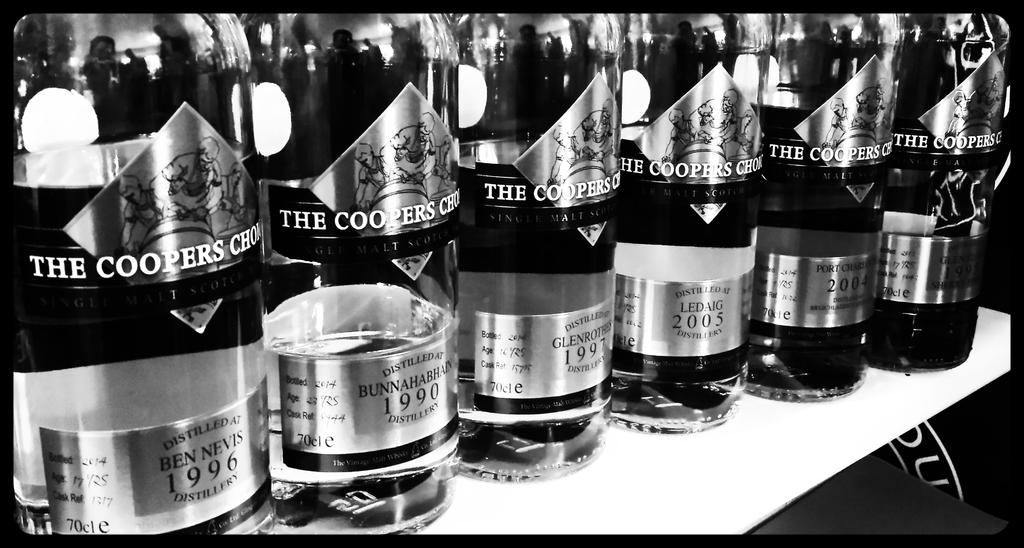<image>
Create a compact narrative representing the image presented. Bottles of alcohol including one that has the year 1996. 